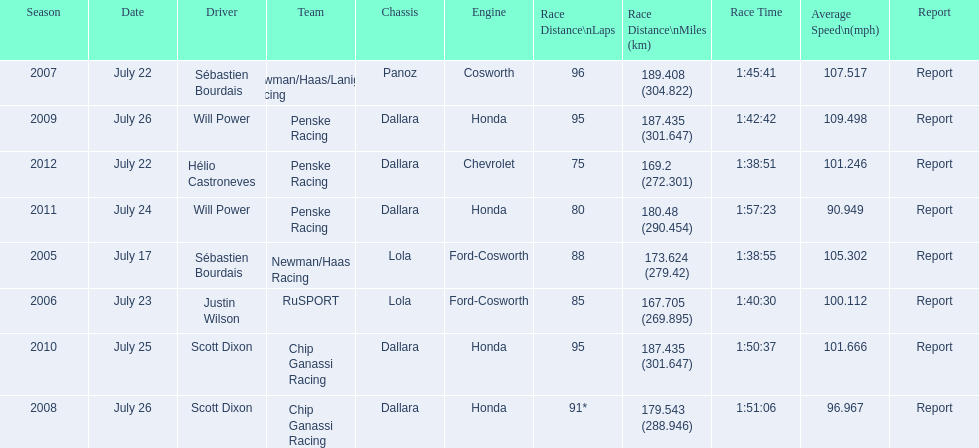Can you give me this table as a dict? {'header': ['Season', 'Date', 'Driver', 'Team', 'Chassis', 'Engine', 'Race Distance\\nLaps', 'Race Distance\\nMiles (km)', 'Race Time', 'Average Speed\\n(mph)', 'Report'], 'rows': [['2007', 'July 22', 'Sébastien Bourdais', 'Newman/Haas/Lanigan Racing', 'Panoz', 'Cosworth', '96', '189.408 (304.822)', '1:45:41', '107.517', 'Report'], ['2009', 'July 26', 'Will Power', 'Penske Racing', 'Dallara', 'Honda', '95', '187.435 (301.647)', '1:42:42', '109.498', 'Report'], ['2012', 'July 22', 'Hélio Castroneves', 'Penske Racing', 'Dallara', 'Chevrolet', '75', '169.2 (272.301)', '1:38:51', '101.246', 'Report'], ['2011', 'July 24', 'Will Power', 'Penske Racing', 'Dallara', 'Honda', '80', '180.48 (290.454)', '1:57:23', '90.949', 'Report'], ['2005', 'July 17', 'Sébastien Bourdais', 'Newman/Haas Racing', 'Lola', 'Ford-Cosworth', '88', '173.624 (279.42)', '1:38:55', '105.302', 'Report'], ['2006', 'July 23', 'Justin Wilson', 'RuSPORT', 'Lola', 'Ford-Cosworth', '85', '167.705 (269.895)', '1:40:30', '100.112', 'Report'], ['2010', 'July 25', 'Scott Dixon', 'Chip Ganassi Racing', 'Dallara', 'Honda', '95', '187.435 (301.647)', '1:50:37', '101.666', 'Report'], ['2008', 'July 26', 'Scott Dixon', 'Chip Ganassi Racing', 'Dallara', 'Honda', '91*', '179.543 (288.946)', '1:51:06', '96.967', 'Report']]} How many total honda engines were there? 4. 